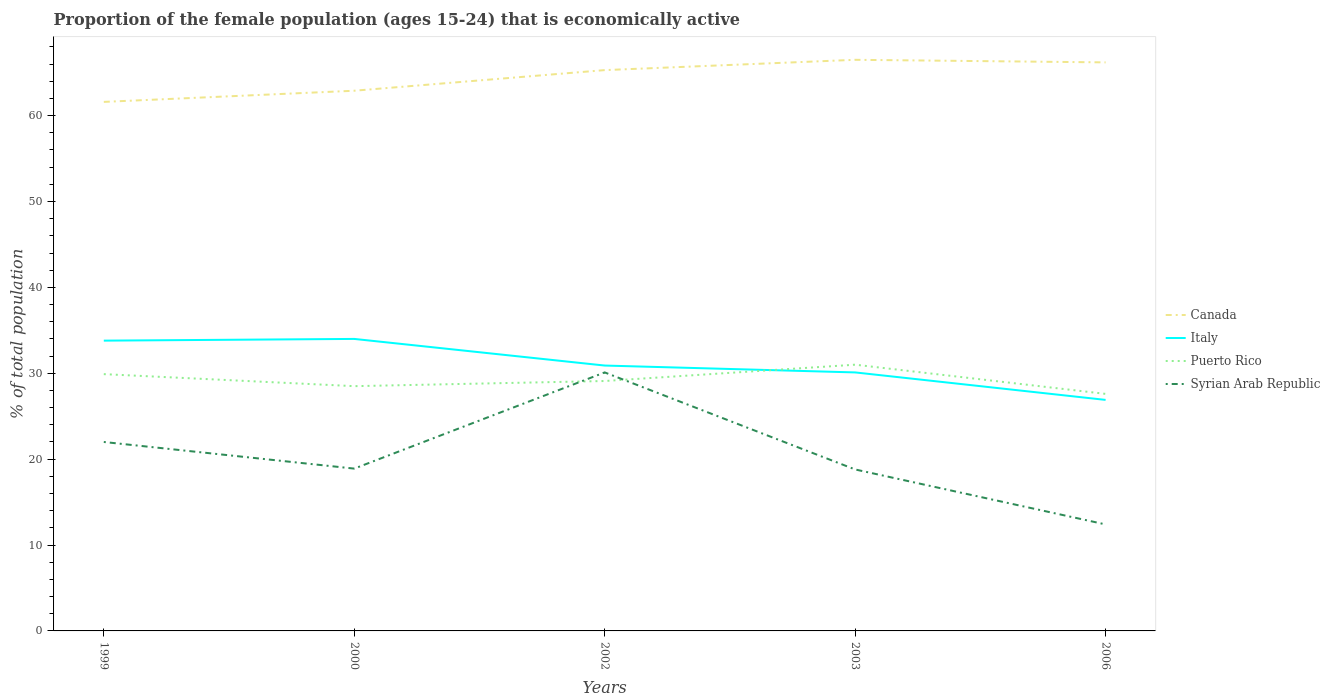Does the line corresponding to Canada intersect with the line corresponding to Puerto Rico?
Give a very brief answer. No. Is the number of lines equal to the number of legend labels?
Ensure brevity in your answer.  Yes. Across all years, what is the maximum proportion of the female population that is economically active in Canada?
Make the answer very short. 61.6. In which year was the proportion of the female population that is economically active in Canada maximum?
Make the answer very short. 1999. What is the total proportion of the female population that is economically active in Italy in the graph?
Your answer should be very brief. 2.9. What is the difference between the highest and the second highest proportion of the female population that is economically active in Puerto Rico?
Provide a succinct answer. 3.4. What is the difference between the highest and the lowest proportion of the female population that is economically active in Italy?
Keep it short and to the point. 2. Is the proportion of the female population that is economically active in Canada strictly greater than the proportion of the female population that is economically active in Puerto Rico over the years?
Give a very brief answer. No. How many lines are there?
Your response must be concise. 4. How many years are there in the graph?
Ensure brevity in your answer.  5. How many legend labels are there?
Provide a succinct answer. 4. What is the title of the graph?
Provide a succinct answer. Proportion of the female population (ages 15-24) that is economically active. What is the label or title of the X-axis?
Offer a very short reply. Years. What is the label or title of the Y-axis?
Offer a terse response. % of total population. What is the % of total population of Canada in 1999?
Your answer should be very brief. 61.6. What is the % of total population of Italy in 1999?
Your answer should be very brief. 33.8. What is the % of total population of Puerto Rico in 1999?
Offer a very short reply. 29.9. What is the % of total population in Canada in 2000?
Your answer should be compact. 62.9. What is the % of total population of Italy in 2000?
Keep it short and to the point. 34. What is the % of total population in Puerto Rico in 2000?
Make the answer very short. 28.5. What is the % of total population in Syrian Arab Republic in 2000?
Make the answer very short. 18.9. What is the % of total population of Canada in 2002?
Provide a short and direct response. 65.3. What is the % of total population of Italy in 2002?
Offer a terse response. 30.9. What is the % of total population in Puerto Rico in 2002?
Your answer should be compact. 29.1. What is the % of total population of Syrian Arab Republic in 2002?
Give a very brief answer. 30.1. What is the % of total population of Canada in 2003?
Your answer should be very brief. 66.5. What is the % of total population of Italy in 2003?
Give a very brief answer. 30.1. What is the % of total population in Puerto Rico in 2003?
Make the answer very short. 31. What is the % of total population of Syrian Arab Republic in 2003?
Your answer should be compact. 18.8. What is the % of total population of Canada in 2006?
Offer a terse response. 66.2. What is the % of total population in Italy in 2006?
Ensure brevity in your answer.  26.9. What is the % of total population in Puerto Rico in 2006?
Offer a very short reply. 27.6. What is the % of total population of Syrian Arab Republic in 2006?
Provide a succinct answer. 12.4. Across all years, what is the maximum % of total population in Canada?
Provide a succinct answer. 66.5. Across all years, what is the maximum % of total population of Syrian Arab Republic?
Your answer should be compact. 30.1. Across all years, what is the minimum % of total population of Canada?
Your answer should be compact. 61.6. Across all years, what is the minimum % of total population of Italy?
Give a very brief answer. 26.9. Across all years, what is the minimum % of total population of Puerto Rico?
Offer a very short reply. 27.6. Across all years, what is the minimum % of total population in Syrian Arab Republic?
Provide a succinct answer. 12.4. What is the total % of total population of Canada in the graph?
Provide a short and direct response. 322.5. What is the total % of total population in Italy in the graph?
Offer a very short reply. 155.7. What is the total % of total population of Puerto Rico in the graph?
Offer a very short reply. 146.1. What is the total % of total population of Syrian Arab Republic in the graph?
Your response must be concise. 102.2. What is the difference between the % of total population in Italy in 1999 and that in 2000?
Your answer should be very brief. -0.2. What is the difference between the % of total population in Syrian Arab Republic in 1999 and that in 2000?
Your response must be concise. 3.1. What is the difference between the % of total population in Canada in 1999 and that in 2002?
Keep it short and to the point. -3.7. What is the difference between the % of total population of Puerto Rico in 1999 and that in 2002?
Offer a terse response. 0.8. What is the difference between the % of total population of Puerto Rico in 1999 and that in 2003?
Provide a short and direct response. -1.1. What is the difference between the % of total population in Canada in 1999 and that in 2006?
Your response must be concise. -4.6. What is the difference between the % of total population of Italy in 1999 and that in 2006?
Provide a succinct answer. 6.9. What is the difference between the % of total population in Syrian Arab Republic in 1999 and that in 2006?
Ensure brevity in your answer.  9.6. What is the difference between the % of total population in Puerto Rico in 2000 and that in 2002?
Offer a terse response. -0.6. What is the difference between the % of total population of Italy in 2000 and that in 2003?
Your answer should be very brief. 3.9. What is the difference between the % of total population in Puerto Rico in 2000 and that in 2003?
Ensure brevity in your answer.  -2.5. What is the difference between the % of total population in Canada in 2000 and that in 2006?
Your answer should be compact. -3.3. What is the difference between the % of total population of Italy in 2002 and that in 2003?
Provide a succinct answer. 0.8. What is the difference between the % of total population of Puerto Rico in 2002 and that in 2003?
Ensure brevity in your answer.  -1.9. What is the difference between the % of total population in Syrian Arab Republic in 2002 and that in 2003?
Keep it short and to the point. 11.3. What is the difference between the % of total population in Canada in 2002 and that in 2006?
Provide a short and direct response. -0.9. What is the difference between the % of total population of Italy in 2002 and that in 2006?
Make the answer very short. 4. What is the difference between the % of total population of Puerto Rico in 2002 and that in 2006?
Give a very brief answer. 1.5. What is the difference between the % of total population of Italy in 2003 and that in 2006?
Offer a terse response. 3.2. What is the difference between the % of total population of Puerto Rico in 2003 and that in 2006?
Offer a very short reply. 3.4. What is the difference between the % of total population in Canada in 1999 and the % of total population in Italy in 2000?
Your response must be concise. 27.6. What is the difference between the % of total population of Canada in 1999 and the % of total population of Puerto Rico in 2000?
Give a very brief answer. 33.1. What is the difference between the % of total population of Canada in 1999 and the % of total population of Syrian Arab Republic in 2000?
Offer a terse response. 42.7. What is the difference between the % of total population of Italy in 1999 and the % of total population of Syrian Arab Republic in 2000?
Your answer should be very brief. 14.9. What is the difference between the % of total population of Puerto Rico in 1999 and the % of total population of Syrian Arab Republic in 2000?
Your answer should be very brief. 11. What is the difference between the % of total population in Canada in 1999 and the % of total population in Italy in 2002?
Make the answer very short. 30.7. What is the difference between the % of total population of Canada in 1999 and the % of total population of Puerto Rico in 2002?
Your answer should be compact. 32.5. What is the difference between the % of total population of Canada in 1999 and the % of total population of Syrian Arab Republic in 2002?
Your answer should be compact. 31.5. What is the difference between the % of total population of Canada in 1999 and the % of total population of Italy in 2003?
Your answer should be compact. 31.5. What is the difference between the % of total population of Canada in 1999 and the % of total population of Puerto Rico in 2003?
Provide a short and direct response. 30.6. What is the difference between the % of total population of Canada in 1999 and the % of total population of Syrian Arab Republic in 2003?
Ensure brevity in your answer.  42.8. What is the difference between the % of total population in Puerto Rico in 1999 and the % of total population in Syrian Arab Republic in 2003?
Provide a succinct answer. 11.1. What is the difference between the % of total population of Canada in 1999 and the % of total population of Italy in 2006?
Offer a terse response. 34.7. What is the difference between the % of total population in Canada in 1999 and the % of total population in Puerto Rico in 2006?
Ensure brevity in your answer.  34. What is the difference between the % of total population in Canada in 1999 and the % of total population in Syrian Arab Republic in 2006?
Provide a short and direct response. 49.2. What is the difference between the % of total population in Italy in 1999 and the % of total population in Puerto Rico in 2006?
Your answer should be compact. 6.2. What is the difference between the % of total population in Italy in 1999 and the % of total population in Syrian Arab Republic in 2006?
Your response must be concise. 21.4. What is the difference between the % of total population of Canada in 2000 and the % of total population of Italy in 2002?
Keep it short and to the point. 32. What is the difference between the % of total population in Canada in 2000 and the % of total population in Puerto Rico in 2002?
Your answer should be very brief. 33.8. What is the difference between the % of total population of Canada in 2000 and the % of total population of Syrian Arab Republic in 2002?
Offer a very short reply. 32.8. What is the difference between the % of total population in Italy in 2000 and the % of total population in Syrian Arab Republic in 2002?
Your answer should be compact. 3.9. What is the difference between the % of total population of Canada in 2000 and the % of total population of Italy in 2003?
Provide a succinct answer. 32.8. What is the difference between the % of total population in Canada in 2000 and the % of total population in Puerto Rico in 2003?
Keep it short and to the point. 31.9. What is the difference between the % of total population of Canada in 2000 and the % of total population of Syrian Arab Republic in 2003?
Make the answer very short. 44.1. What is the difference between the % of total population in Puerto Rico in 2000 and the % of total population in Syrian Arab Republic in 2003?
Your response must be concise. 9.7. What is the difference between the % of total population in Canada in 2000 and the % of total population in Italy in 2006?
Provide a short and direct response. 36. What is the difference between the % of total population of Canada in 2000 and the % of total population of Puerto Rico in 2006?
Your answer should be very brief. 35.3. What is the difference between the % of total population in Canada in 2000 and the % of total population in Syrian Arab Republic in 2006?
Ensure brevity in your answer.  50.5. What is the difference between the % of total population in Italy in 2000 and the % of total population in Puerto Rico in 2006?
Your answer should be very brief. 6.4. What is the difference between the % of total population of Italy in 2000 and the % of total population of Syrian Arab Republic in 2006?
Provide a succinct answer. 21.6. What is the difference between the % of total population of Puerto Rico in 2000 and the % of total population of Syrian Arab Republic in 2006?
Provide a succinct answer. 16.1. What is the difference between the % of total population in Canada in 2002 and the % of total population in Italy in 2003?
Your answer should be compact. 35.2. What is the difference between the % of total population in Canada in 2002 and the % of total population in Puerto Rico in 2003?
Keep it short and to the point. 34.3. What is the difference between the % of total population in Canada in 2002 and the % of total population in Syrian Arab Republic in 2003?
Offer a very short reply. 46.5. What is the difference between the % of total population of Canada in 2002 and the % of total population of Italy in 2006?
Offer a terse response. 38.4. What is the difference between the % of total population in Canada in 2002 and the % of total population in Puerto Rico in 2006?
Offer a terse response. 37.7. What is the difference between the % of total population of Canada in 2002 and the % of total population of Syrian Arab Republic in 2006?
Make the answer very short. 52.9. What is the difference between the % of total population of Canada in 2003 and the % of total population of Italy in 2006?
Your answer should be very brief. 39.6. What is the difference between the % of total population in Canada in 2003 and the % of total population in Puerto Rico in 2006?
Make the answer very short. 38.9. What is the difference between the % of total population in Canada in 2003 and the % of total population in Syrian Arab Republic in 2006?
Offer a terse response. 54.1. What is the difference between the % of total population in Italy in 2003 and the % of total population in Puerto Rico in 2006?
Make the answer very short. 2.5. What is the difference between the % of total population of Italy in 2003 and the % of total population of Syrian Arab Republic in 2006?
Keep it short and to the point. 17.7. What is the difference between the % of total population of Puerto Rico in 2003 and the % of total population of Syrian Arab Republic in 2006?
Your answer should be compact. 18.6. What is the average % of total population in Canada per year?
Provide a succinct answer. 64.5. What is the average % of total population in Italy per year?
Provide a short and direct response. 31.14. What is the average % of total population in Puerto Rico per year?
Your answer should be very brief. 29.22. What is the average % of total population in Syrian Arab Republic per year?
Your answer should be compact. 20.44. In the year 1999, what is the difference between the % of total population of Canada and % of total population of Italy?
Offer a terse response. 27.8. In the year 1999, what is the difference between the % of total population of Canada and % of total population of Puerto Rico?
Ensure brevity in your answer.  31.7. In the year 1999, what is the difference between the % of total population in Canada and % of total population in Syrian Arab Republic?
Provide a short and direct response. 39.6. In the year 1999, what is the difference between the % of total population in Italy and % of total population in Syrian Arab Republic?
Provide a succinct answer. 11.8. In the year 2000, what is the difference between the % of total population of Canada and % of total population of Italy?
Offer a terse response. 28.9. In the year 2000, what is the difference between the % of total population in Canada and % of total population in Puerto Rico?
Ensure brevity in your answer.  34.4. In the year 2000, what is the difference between the % of total population of Canada and % of total population of Syrian Arab Republic?
Offer a very short reply. 44. In the year 2000, what is the difference between the % of total population in Italy and % of total population in Syrian Arab Republic?
Your response must be concise. 15.1. In the year 2002, what is the difference between the % of total population in Canada and % of total population in Italy?
Give a very brief answer. 34.4. In the year 2002, what is the difference between the % of total population of Canada and % of total population of Puerto Rico?
Make the answer very short. 36.2. In the year 2002, what is the difference between the % of total population in Canada and % of total population in Syrian Arab Republic?
Make the answer very short. 35.2. In the year 2002, what is the difference between the % of total population of Italy and % of total population of Syrian Arab Republic?
Your answer should be very brief. 0.8. In the year 2002, what is the difference between the % of total population of Puerto Rico and % of total population of Syrian Arab Republic?
Give a very brief answer. -1. In the year 2003, what is the difference between the % of total population of Canada and % of total population of Italy?
Offer a very short reply. 36.4. In the year 2003, what is the difference between the % of total population in Canada and % of total population in Puerto Rico?
Your answer should be compact. 35.5. In the year 2003, what is the difference between the % of total population in Canada and % of total population in Syrian Arab Republic?
Your answer should be very brief. 47.7. In the year 2003, what is the difference between the % of total population of Italy and % of total population of Puerto Rico?
Provide a succinct answer. -0.9. In the year 2003, what is the difference between the % of total population of Italy and % of total population of Syrian Arab Republic?
Offer a very short reply. 11.3. In the year 2006, what is the difference between the % of total population in Canada and % of total population in Italy?
Offer a very short reply. 39.3. In the year 2006, what is the difference between the % of total population of Canada and % of total population of Puerto Rico?
Offer a terse response. 38.6. In the year 2006, what is the difference between the % of total population in Canada and % of total population in Syrian Arab Republic?
Make the answer very short. 53.8. In the year 2006, what is the difference between the % of total population of Italy and % of total population of Puerto Rico?
Provide a short and direct response. -0.7. In the year 2006, what is the difference between the % of total population of Puerto Rico and % of total population of Syrian Arab Republic?
Offer a terse response. 15.2. What is the ratio of the % of total population in Canada in 1999 to that in 2000?
Provide a short and direct response. 0.98. What is the ratio of the % of total population of Italy in 1999 to that in 2000?
Offer a terse response. 0.99. What is the ratio of the % of total population in Puerto Rico in 1999 to that in 2000?
Make the answer very short. 1.05. What is the ratio of the % of total population in Syrian Arab Republic in 1999 to that in 2000?
Your answer should be compact. 1.16. What is the ratio of the % of total population of Canada in 1999 to that in 2002?
Offer a terse response. 0.94. What is the ratio of the % of total population in Italy in 1999 to that in 2002?
Your answer should be very brief. 1.09. What is the ratio of the % of total population in Puerto Rico in 1999 to that in 2002?
Offer a very short reply. 1.03. What is the ratio of the % of total population of Syrian Arab Republic in 1999 to that in 2002?
Make the answer very short. 0.73. What is the ratio of the % of total population of Canada in 1999 to that in 2003?
Provide a short and direct response. 0.93. What is the ratio of the % of total population in Italy in 1999 to that in 2003?
Keep it short and to the point. 1.12. What is the ratio of the % of total population in Puerto Rico in 1999 to that in 2003?
Give a very brief answer. 0.96. What is the ratio of the % of total population in Syrian Arab Republic in 1999 to that in 2003?
Your response must be concise. 1.17. What is the ratio of the % of total population of Canada in 1999 to that in 2006?
Give a very brief answer. 0.93. What is the ratio of the % of total population of Italy in 1999 to that in 2006?
Offer a very short reply. 1.26. What is the ratio of the % of total population in Puerto Rico in 1999 to that in 2006?
Offer a very short reply. 1.08. What is the ratio of the % of total population in Syrian Arab Republic in 1999 to that in 2006?
Make the answer very short. 1.77. What is the ratio of the % of total population of Canada in 2000 to that in 2002?
Ensure brevity in your answer.  0.96. What is the ratio of the % of total population in Italy in 2000 to that in 2002?
Make the answer very short. 1.1. What is the ratio of the % of total population of Puerto Rico in 2000 to that in 2002?
Offer a terse response. 0.98. What is the ratio of the % of total population in Syrian Arab Republic in 2000 to that in 2002?
Ensure brevity in your answer.  0.63. What is the ratio of the % of total population in Canada in 2000 to that in 2003?
Your answer should be very brief. 0.95. What is the ratio of the % of total population of Italy in 2000 to that in 2003?
Offer a terse response. 1.13. What is the ratio of the % of total population of Puerto Rico in 2000 to that in 2003?
Your answer should be compact. 0.92. What is the ratio of the % of total population of Syrian Arab Republic in 2000 to that in 2003?
Offer a terse response. 1.01. What is the ratio of the % of total population in Canada in 2000 to that in 2006?
Give a very brief answer. 0.95. What is the ratio of the % of total population in Italy in 2000 to that in 2006?
Provide a succinct answer. 1.26. What is the ratio of the % of total population of Puerto Rico in 2000 to that in 2006?
Provide a short and direct response. 1.03. What is the ratio of the % of total population in Syrian Arab Republic in 2000 to that in 2006?
Make the answer very short. 1.52. What is the ratio of the % of total population of Canada in 2002 to that in 2003?
Ensure brevity in your answer.  0.98. What is the ratio of the % of total population of Italy in 2002 to that in 2003?
Offer a very short reply. 1.03. What is the ratio of the % of total population of Puerto Rico in 2002 to that in 2003?
Make the answer very short. 0.94. What is the ratio of the % of total population in Syrian Arab Republic in 2002 to that in 2003?
Your answer should be compact. 1.6. What is the ratio of the % of total population of Canada in 2002 to that in 2006?
Offer a very short reply. 0.99. What is the ratio of the % of total population in Italy in 2002 to that in 2006?
Give a very brief answer. 1.15. What is the ratio of the % of total population of Puerto Rico in 2002 to that in 2006?
Provide a succinct answer. 1.05. What is the ratio of the % of total population in Syrian Arab Republic in 2002 to that in 2006?
Your answer should be very brief. 2.43. What is the ratio of the % of total population in Italy in 2003 to that in 2006?
Provide a succinct answer. 1.12. What is the ratio of the % of total population of Puerto Rico in 2003 to that in 2006?
Offer a terse response. 1.12. What is the ratio of the % of total population in Syrian Arab Republic in 2003 to that in 2006?
Give a very brief answer. 1.52. What is the difference between the highest and the second highest % of total population in Puerto Rico?
Offer a terse response. 1.1. What is the difference between the highest and the second highest % of total population of Syrian Arab Republic?
Provide a succinct answer. 8.1. What is the difference between the highest and the lowest % of total population of Puerto Rico?
Give a very brief answer. 3.4. What is the difference between the highest and the lowest % of total population of Syrian Arab Republic?
Provide a short and direct response. 17.7. 